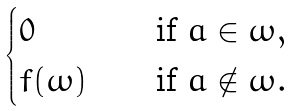<formula> <loc_0><loc_0><loc_500><loc_500>\begin{cases} 0 \quad & \text {if $a\in\omega$} , \\ f ( \omega ) \quad & \text {if $a\notin\omega$} . \end{cases}</formula> 